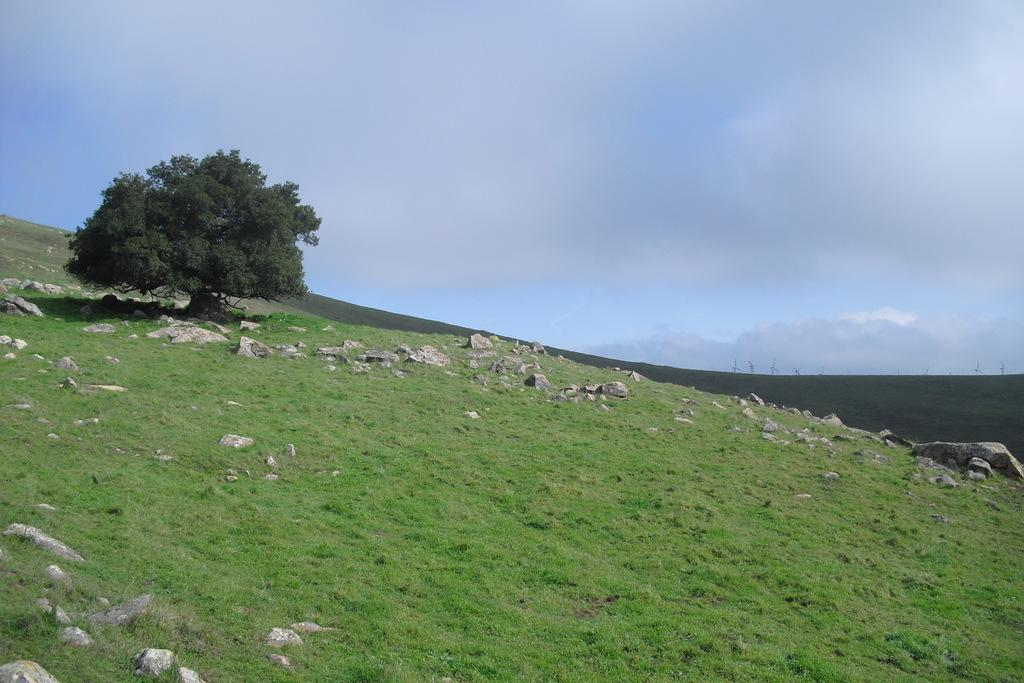What type of environment is depicted in the image? The image is an outside view. What can be seen on the ground in the image? There are many stones and grass on the ground. Where is the tree located in the image? The tree is on the left side of the image. What is visible at the top of the image? The sky is visible at the top of the image. What type of riddle is hidden in the grass in the image? There is no riddle hidden in the grass in the image. Can you tell me the flavor of the jam on the tree in the image? There is no jam present on the tree in the image. 